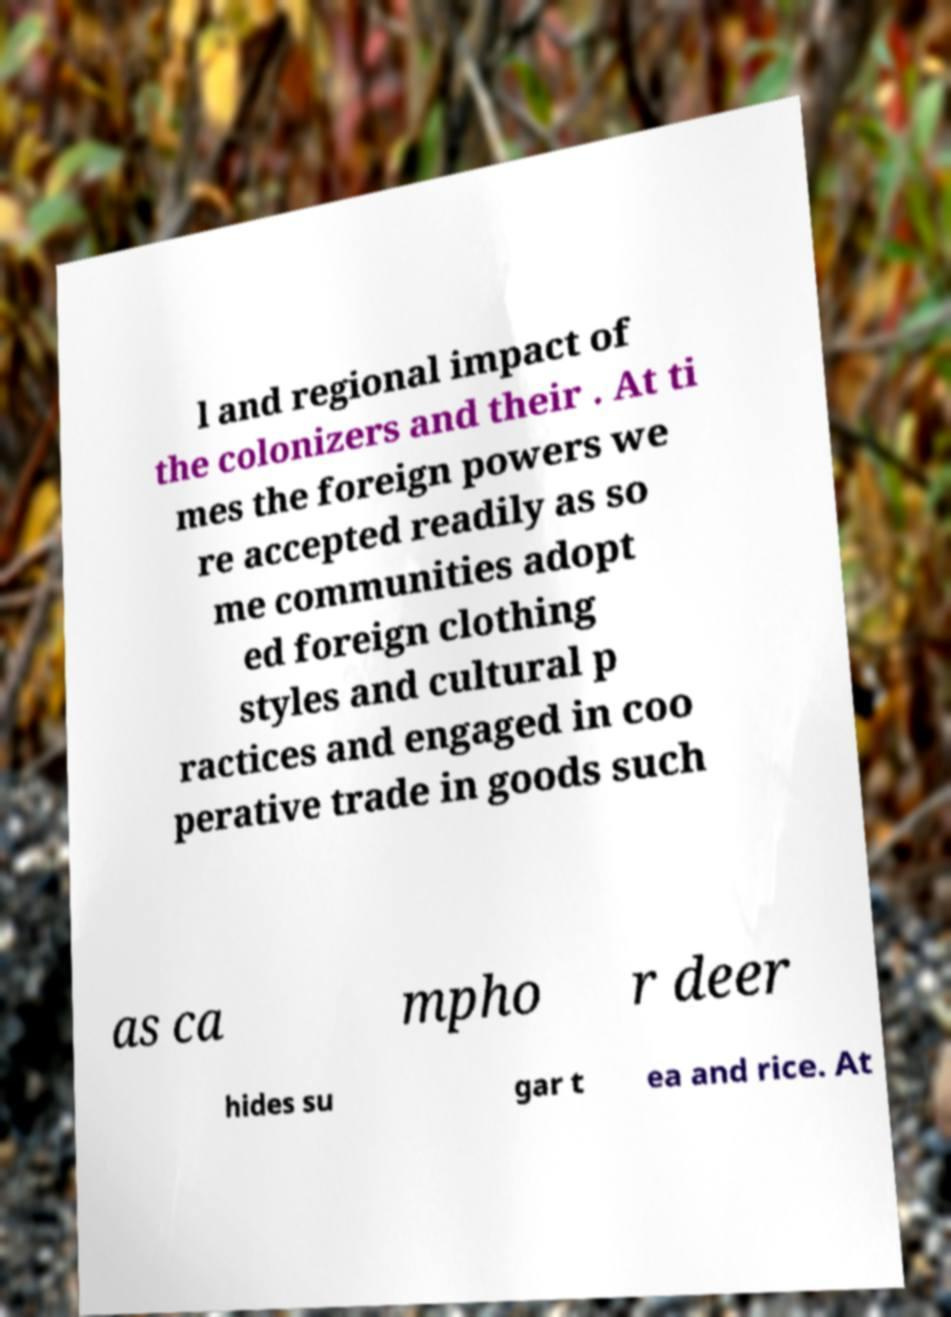For documentation purposes, I need the text within this image transcribed. Could you provide that? l and regional impact of the colonizers and their . At ti mes the foreign powers we re accepted readily as so me communities adopt ed foreign clothing styles and cultural p ractices and engaged in coo perative trade in goods such as ca mpho r deer hides su gar t ea and rice. At 